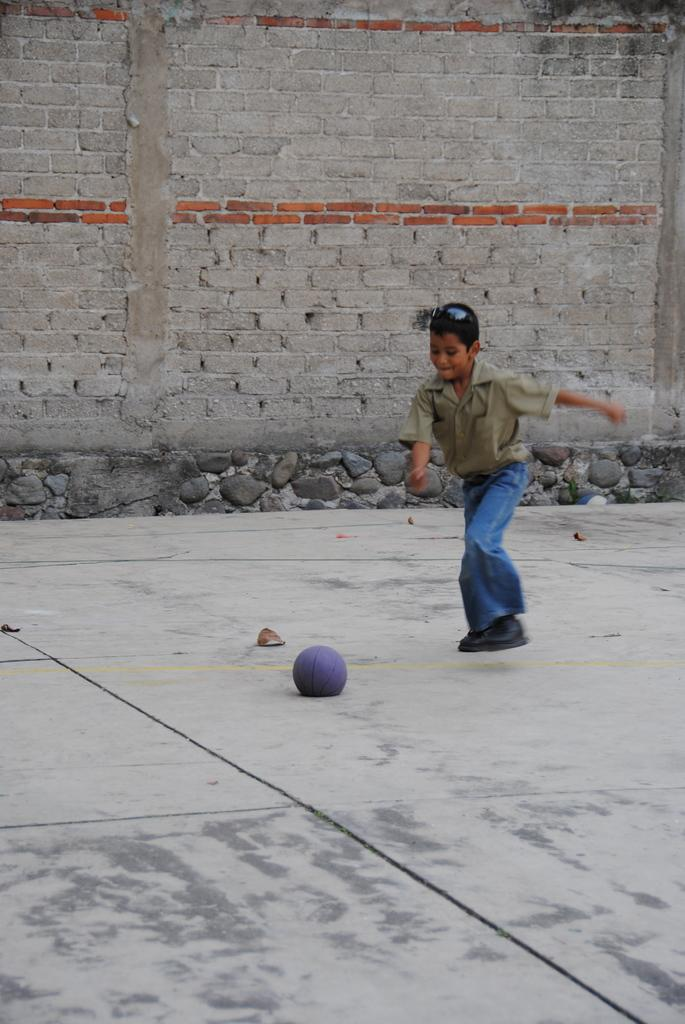Who is the main subject in the image? There is a boy in the image. What is the boy wearing? The boy is wearing jeans. What is the boy doing in the image? The boy is playing with a ball. Where is the boy located in the image? The boy is on a floor. What can be seen in the background of the image? There is a brick wall in the background of the image. What is the name of the suggestion the boy made in the image? There is no suggestion made by the boy in the image; he is simply playing with a ball. 